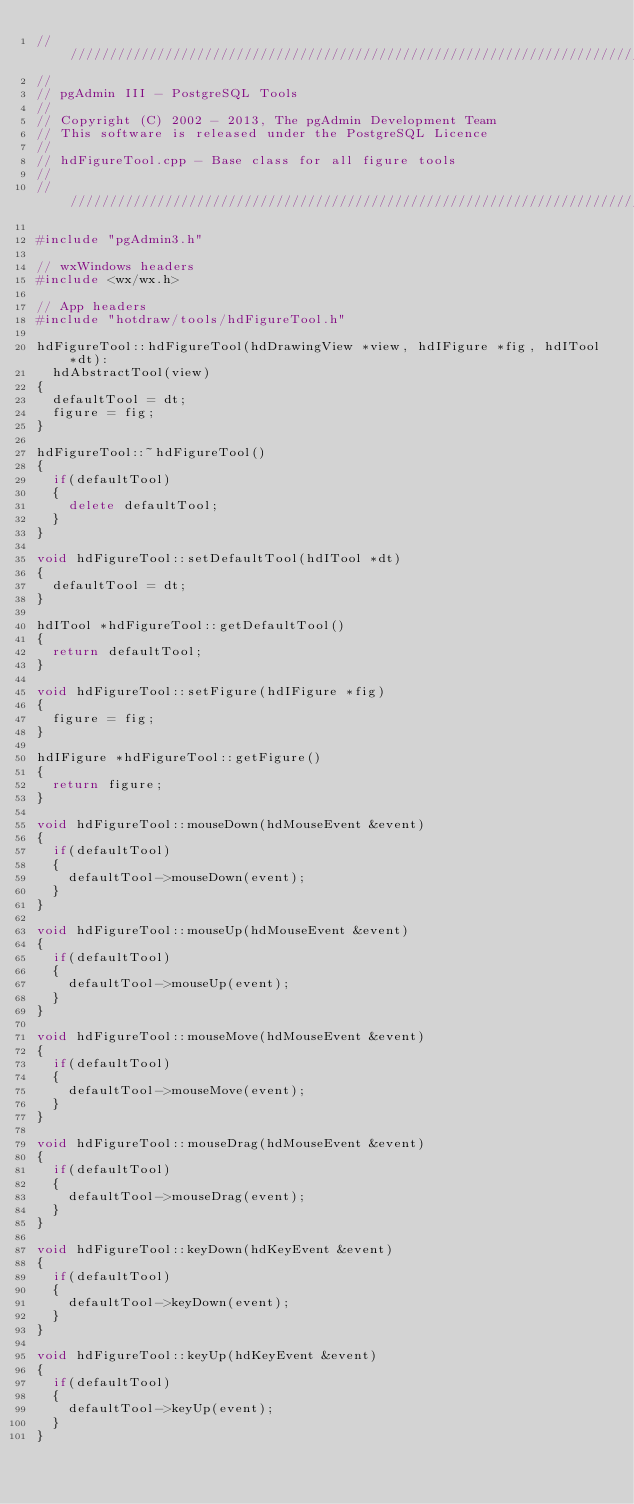<code> <loc_0><loc_0><loc_500><loc_500><_C++_>//////////////////////////////////////////////////////////////////////////
//
// pgAdmin III - PostgreSQL Tools
//
// Copyright (C) 2002 - 2013, The pgAdmin Development Team
// This software is released under the PostgreSQL Licence
//
// hdFigureTool.cpp - Base class for all figure tools
//
//////////////////////////////////////////////////////////////////////////

#include "pgAdmin3.h"

// wxWindows headers
#include <wx/wx.h>

// App headers
#include "hotdraw/tools/hdFigureTool.h"

hdFigureTool::hdFigureTool(hdDrawingView *view, hdIFigure *fig, hdITool *dt):
	hdAbstractTool(view)
{
	defaultTool = dt;
	figure = fig;
}

hdFigureTool::~hdFigureTool()
{
	if(defaultTool)
	{
		delete defaultTool;
	}
}

void hdFigureTool::setDefaultTool(hdITool *dt)
{
	defaultTool = dt;
}

hdITool *hdFigureTool::getDefaultTool()
{
	return defaultTool;
}

void hdFigureTool::setFigure(hdIFigure *fig)
{
	figure = fig;
}

hdIFigure *hdFigureTool::getFigure()
{
	return figure;
}

void hdFigureTool::mouseDown(hdMouseEvent &event)
{
	if(defaultTool)
	{
		defaultTool->mouseDown(event);
	}
}

void hdFigureTool::mouseUp(hdMouseEvent &event)
{
	if(defaultTool)
	{
		defaultTool->mouseUp(event);
	}
}

void hdFigureTool::mouseMove(hdMouseEvent &event)
{
	if(defaultTool)
	{
		defaultTool->mouseMove(event);
	}
}

void hdFigureTool::mouseDrag(hdMouseEvent &event)
{
	if(defaultTool)
	{
		defaultTool->mouseDrag(event);
	}
}

void hdFigureTool::keyDown(hdKeyEvent &event)
{
	if(defaultTool)
	{
		defaultTool->keyDown(event);
	}
}

void hdFigureTool::keyUp(hdKeyEvent &event)
{
	if(defaultTool)
	{
		defaultTool->keyUp(event);
	}
}
</code> 